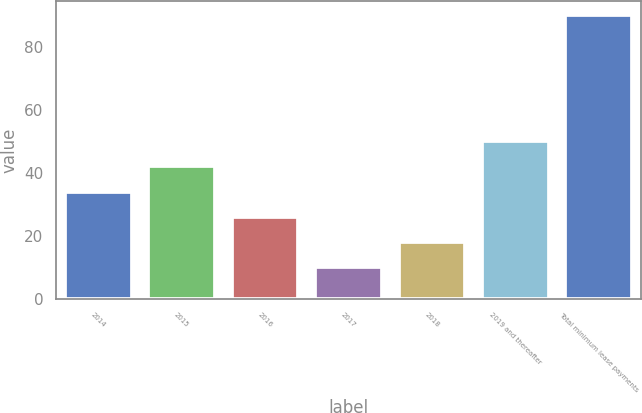Convert chart to OTSL. <chart><loc_0><loc_0><loc_500><loc_500><bar_chart><fcel>2014<fcel>2015<fcel>2016<fcel>2017<fcel>2018<fcel>2019 and thereafter<fcel>Total minimum lease payments<nl><fcel>34<fcel>42<fcel>26<fcel>10<fcel>18<fcel>50<fcel>90<nl></chart> 